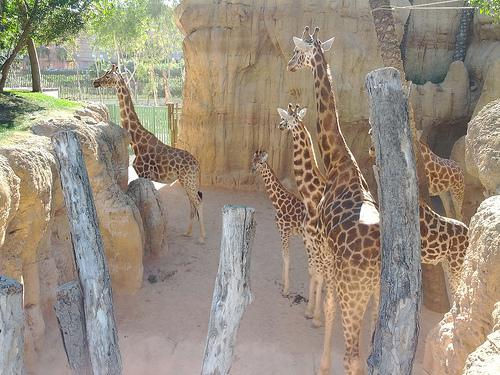Question: what color are the giraffes?
Choices:
A. Yellow and brown.
B. Grey.
C. White.
D. Black and yellow.
Answer with the letter. Answer: A Question: why are the giraffes behind a fence?
Choices:
A. It is an exhibit.
B. For their safety.
C. Nature preserve.
D. It's a pet.
Answer with the letter. Answer: A Question: what direction are the giraffes facing?
Choices:
A. To the North.
B. To the South.
C. To the West.
D. Toward the sunlight.
Answer with the letter. Answer: D Question: how many giraffes are there?
Choices:
A. 7.
B. 8.
C. 5.
D. 9.
Answer with the letter. Answer: C Question: who is the animal shown in the picture?
Choices:
A. Horse.
B. Dog.
C. Giraffes.
D. Cat.
Answer with the letter. Answer: C Question: when was the photo of the giraffes taken?
Choices:
A. At night.
B. During the late evening.
C. During the daytime.
D. In the morning.
Answer with the letter. Answer: C Question: what is blocking the view of the giraffes?
Choices:
A. A dead tree.
B. Trees.
C. Hillside.
D. Vehicles.
Answer with the letter. Answer: A 